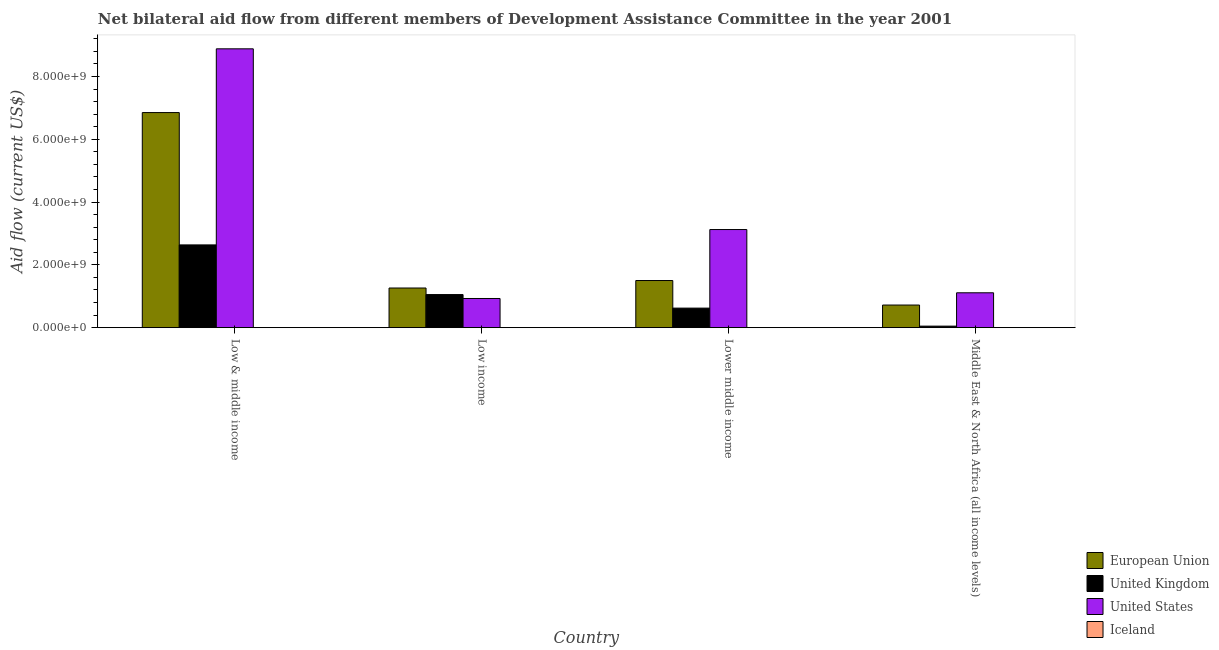How many groups of bars are there?
Ensure brevity in your answer.  4. Are the number of bars on each tick of the X-axis equal?
Provide a short and direct response. Yes. How many bars are there on the 1st tick from the left?
Your response must be concise. 4. What is the label of the 1st group of bars from the left?
Offer a very short reply. Low & middle income. In how many cases, is the number of bars for a given country not equal to the number of legend labels?
Your response must be concise. 0. What is the amount of aid given by eu in Low income?
Offer a very short reply. 1.26e+09. Across all countries, what is the maximum amount of aid given by eu?
Keep it short and to the point. 6.85e+09. Across all countries, what is the minimum amount of aid given by iceland?
Keep it short and to the point. 2.00e+04. In which country was the amount of aid given by eu minimum?
Your response must be concise. Middle East & North Africa (all income levels). What is the total amount of aid given by us in the graph?
Provide a short and direct response. 1.40e+1. What is the difference between the amount of aid given by uk in Low & middle income and that in Lower middle income?
Provide a short and direct response. 2.01e+09. What is the difference between the amount of aid given by eu in Lower middle income and the amount of aid given by uk in Low & middle income?
Keep it short and to the point. -1.13e+09. What is the average amount of aid given by us per country?
Provide a short and direct response. 3.51e+09. What is the difference between the amount of aid given by uk and amount of aid given by iceland in Lower middle income?
Provide a short and direct response. 6.21e+08. In how many countries, is the amount of aid given by us greater than 2000000000 US$?
Offer a very short reply. 2. What is the ratio of the amount of aid given by eu in Low & middle income to that in Lower middle income?
Offer a terse response. 4.56. Is the amount of aid given by uk in Lower middle income less than that in Middle East & North Africa (all income levels)?
Offer a very short reply. No. What is the difference between the highest and the second highest amount of aid given by uk?
Keep it short and to the point. 1.58e+09. What is the difference between the highest and the lowest amount of aid given by us?
Your response must be concise. 7.95e+09. Is it the case that in every country, the sum of the amount of aid given by uk and amount of aid given by us is greater than the sum of amount of aid given by iceland and amount of aid given by eu?
Your answer should be very brief. No. Is it the case that in every country, the sum of the amount of aid given by eu and amount of aid given by uk is greater than the amount of aid given by us?
Ensure brevity in your answer.  No. How many countries are there in the graph?
Keep it short and to the point. 4. What is the difference between two consecutive major ticks on the Y-axis?
Offer a terse response. 2.00e+09. How many legend labels are there?
Provide a succinct answer. 4. What is the title of the graph?
Your answer should be very brief. Net bilateral aid flow from different members of Development Assistance Committee in the year 2001. What is the label or title of the X-axis?
Make the answer very short. Country. What is the label or title of the Y-axis?
Your answer should be compact. Aid flow (current US$). What is the Aid flow (current US$) in European Union in Low & middle income?
Ensure brevity in your answer.  6.85e+09. What is the Aid flow (current US$) of United Kingdom in Low & middle income?
Ensure brevity in your answer.  2.64e+09. What is the Aid flow (current US$) in United States in Low & middle income?
Your answer should be very brief. 8.88e+09. What is the Aid flow (current US$) of Iceland in Low & middle income?
Offer a very short reply. 2.00e+04. What is the Aid flow (current US$) in European Union in Low income?
Provide a succinct answer. 1.26e+09. What is the Aid flow (current US$) of United Kingdom in Low income?
Offer a very short reply. 1.05e+09. What is the Aid flow (current US$) of United States in Low income?
Keep it short and to the point. 9.29e+08. What is the Aid flow (current US$) in Iceland in Low income?
Ensure brevity in your answer.  1.74e+06. What is the Aid flow (current US$) of European Union in Lower middle income?
Make the answer very short. 1.50e+09. What is the Aid flow (current US$) in United Kingdom in Lower middle income?
Your answer should be compact. 6.23e+08. What is the Aid flow (current US$) of United States in Lower middle income?
Provide a short and direct response. 3.13e+09. What is the Aid flow (current US$) of Iceland in Lower middle income?
Your answer should be very brief. 1.30e+06. What is the Aid flow (current US$) in European Union in Middle East & North Africa (all income levels)?
Provide a succinct answer. 7.21e+08. What is the Aid flow (current US$) in United Kingdom in Middle East & North Africa (all income levels)?
Make the answer very short. 4.88e+07. What is the Aid flow (current US$) of United States in Middle East & North Africa (all income levels)?
Offer a very short reply. 1.11e+09. What is the Aid flow (current US$) in Iceland in Middle East & North Africa (all income levels)?
Your answer should be compact. 9.70e+05. Across all countries, what is the maximum Aid flow (current US$) in European Union?
Offer a terse response. 6.85e+09. Across all countries, what is the maximum Aid flow (current US$) in United Kingdom?
Provide a succinct answer. 2.64e+09. Across all countries, what is the maximum Aid flow (current US$) in United States?
Ensure brevity in your answer.  8.88e+09. Across all countries, what is the maximum Aid flow (current US$) of Iceland?
Your response must be concise. 1.74e+06. Across all countries, what is the minimum Aid flow (current US$) in European Union?
Ensure brevity in your answer.  7.21e+08. Across all countries, what is the minimum Aid flow (current US$) in United Kingdom?
Offer a very short reply. 4.88e+07. Across all countries, what is the minimum Aid flow (current US$) in United States?
Your answer should be very brief. 9.29e+08. What is the total Aid flow (current US$) in European Union in the graph?
Your response must be concise. 1.03e+1. What is the total Aid flow (current US$) in United Kingdom in the graph?
Keep it short and to the point. 4.36e+09. What is the total Aid flow (current US$) of United States in the graph?
Your response must be concise. 1.40e+1. What is the total Aid flow (current US$) of Iceland in the graph?
Your response must be concise. 4.03e+06. What is the difference between the Aid flow (current US$) in European Union in Low & middle income and that in Low income?
Your answer should be very brief. 5.59e+09. What is the difference between the Aid flow (current US$) in United Kingdom in Low & middle income and that in Low income?
Keep it short and to the point. 1.58e+09. What is the difference between the Aid flow (current US$) in United States in Low & middle income and that in Low income?
Give a very brief answer. 7.95e+09. What is the difference between the Aid flow (current US$) of Iceland in Low & middle income and that in Low income?
Give a very brief answer. -1.72e+06. What is the difference between the Aid flow (current US$) of European Union in Low & middle income and that in Lower middle income?
Your answer should be compact. 5.35e+09. What is the difference between the Aid flow (current US$) in United Kingdom in Low & middle income and that in Lower middle income?
Make the answer very short. 2.01e+09. What is the difference between the Aid flow (current US$) of United States in Low & middle income and that in Lower middle income?
Offer a terse response. 5.76e+09. What is the difference between the Aid flow (current US$) in Iceland in Low & middle income and that in Lower middle income?
Give a very brief answer. -1.28e+06. What is the difference between the Aid flow (current US$) in European Union in Low & middle income and that in Middle East & North Africa (all income levels)?
Ensure brevity in your answer.  6.13e+09. What is the difference between the Aid flow (current US$) in United Kingdom in Low & middle income and that in Middle East & North Africa (all income levels)?
Your answer should be very brief. 2.59e+09. What is the difference between the Aid flow (current US$) in United States in Low & middle income and that in Middle East & North Africa (all income levels)?
Make the answer very short. 7.77e+09. What is the difference between the Aid flow (current US$) in Iceland in Low & middle income and that in Middle East & North Africa (all income levels)?
Keep it short and to the point. -9.50e+05. What is the difference between the Aid flow (current US$) in European Union in Low income and that in Lower middle income?
Give a very brief answer. -2.38e+08. What is the difference between the Aid flow (current US$) of United Kingdom in Low income and that in Lower middle income?
Your answer should be very brief. 4.31e+08. What is the difference between the Aid flow (current US$) of United States in Low income and that in Lower middle income?
Provide a succinct answer. -2.20e+09. What is the difference between the Aid flow (current US$) in European Union in Low income and that in Middle East & North Africa (all income levels)?
Your response must be concise. 5.42e+08. What is the difference between the Aid flow (current US$) of United Kingdom in Low income and that in Middle East & North Africa (all income levels)?
Provide a short and direct response. 1.01e+09. What is the difference between the Aid flow (current US$) in United States in Low income and that in Middle East & North Africa (all income levels)?
Your answer should be very brief. -1.82e+08. What is the difference between the Aid flow (current US$) in Iceland in Low income and that in Middle East & North Africa (all income levels)?
Provide a short and direct response. 7.70e+05. What is the difference between the Aid flow (current US$) in European Union in Lower middle income and that in Middle East & North Africa (all income levels)?
Your answer should be very brief. 7.81e+08. What is the difference between the Aid flow (current US$) of United Kingdom in Lower middle income and that in Middle East & North Africa (all income levels)?
Ensure brevity in your answer.  5.74e+08. What is the difference between the Aid flow (current US$) of United States in Lower middle income and that in Middle East & North Africa (all income levels)?
Provide a short and direct response. 2.01e+09. What is the difference between the Aid flow (current US$) in Iceland in Lower middle income and that in Middle East & North Africa (all income levels)?
Ensure brevity in your answer.  3.30e+05. What is the difference between the Aid flow (current US$) of European Union in Low & middle income and the Aid flow (current US$) of United Kingdom in Low income?
Offer a very short reply. 5.80e+09. What is the difference between the Aid flow (current US$) in European Union in Low & middle income and the Aid flow (current US$) in United States in Low income?
Keep it short and to the point. 5.92e+09. What is the difference between the Aid flow (current US$) in European Union in Low & middle income and the Aid flow (current US$) in Iceland in Low income?
Offer a very short reply. 6.85e+09. What is the difference between the Aid flow (current US$) of United Kingdom in Low & middle income and the Aid flow (current US$) of United States in Low income?
Your answer should be compact. 1.71e+09. What is the difference between the Aid flow (current US$) in United Kingdom in Low & middle income and the Aid flow (current US$) in Iceland in Low income?
Offer a terse response. 2.63e+09. What is the difference between the Aid flow (current US$) in United States in Low & middle income and the Aid flow (current US$) in Iceland in Low income?
Make the answer very short. 8.88e+09. What is the difference between the Aid flow (current US$) in European Union in Low & middle income and the Aid flow (current US$) in United Kingdom in Lower middle income?
Your answer should be very brief. 6.23e+09. What is the difference between the Aid flow (current US$) in European Union in Low & middle income and the Aid flow (current US$) in United States in Lower middle income?
Your response must be concise. 3.73e+09. What is the difference between the Aid flow (current US$) in European Union in Low & middle income and the Aid flow (current US$) in Iceland in Lower middle income?
Give a very brief answer. 6.85e+09. What is the difference between the Aid flow (current US$) in United Kingdom in Low & middle income and the Aid flow (current US$) in United States in Lower middle income?
Offer a very short reply. -4.89e+08. What is the difference between the Aid flow (current US$) in United Kingdom in Low & middle income and the Aid flow (current US$) in Iceland in Lower middle income?
Offer a very short reply. 2.63e+09. What is the difference between the Aid flow (current US$) in United States in Low & middle income and the Aid flow (current US$) in Iceland in Lower middle income?
Your response must be concise. 8.88e+09. What is the difference between the Aid flow (current US$) in European Union in Low & middle income and the Aid flow (current US$) in United Kingdom in Middle East & North Africa (all income levels)?
Keep it short and to the point. 6.80e+09. What is the difference between the Aid flow (current US$) in European Union in Low & middle income and the Aid flow (current US$) in United States in Middle East & North Africa (all income levels)?
Provide a succinct answer. 5.74e+09. What is the difference between the Aid flow (current US$) in European Union in Low & middle income and the Aid flow (current US$) in Iceland in Middle East & North Africa (all income levels)?
Offer a terse response. 6.85e+09. What is the difference between the Aid flow (current US$) in United Kingdom in Low & middle income and the Aid flow (current US$) in United States in Middle East & North Africa (all income levels)?
Give a very brief answer. 1.53e+09. What is the difference between the Aid flow (current US$) of United Kingdom in Low & middle income and the Aid flow (current US$) of Iceland in Middle East & North Africa (all income levels)?
Ensure brevity in your answer.  2.64e+09. What is the difference between the Aid flow (current US$) of United States in Low & middle income and the Aid flow (current US$) of Iceland in Middle East & North Africa (all income levels)?
Keep it short and to the point. 8.88e+09. What is the difference between the Aid flow (current US$) in European Union in Low income and the Aid flow (current US$) in United Kingdom in Lower middle income?
Offer a very short reply. 6.41e+08. What is the difference between the Aid flow (current US$) in European Union in Low income and the Aid flow (current US$) in United States in Lower middle income?
Provide a succinct answer. -1.86e+09. What is the difference between the Aid flow (current US$) of European Union in Low income and the Aid flow (current US$) of Iceland in Lower middle income?
Ensure brevity in your answer.  1.26e+09. What is the difference between the Aid flow (current US$) in United Kingdom in Low income and the Aid flow (current US$) in United States in Lower middle income?
Make the answer very short. -2.07e+09. What is the difference between the Aid flow (current US$) of United Kingdom in Low income and the Aid flow (current US$) of Iceland in Lower middle income?
Your answer should be compact. 1.05e+09. What is the difference between the Aid flow (current US$) of United States in Low income and the Aid flow (current US$) of Iceland in Lower middle income?
Your answer should be compact. 9.28e+08. What is the difference between the Aid flow (current US$) of European Union in Low income and the Aid flow (current US$) of United Kingdom in Middle East & North Africa (all income levels)?
Offer a very short reply. 1.21e+09. What is the difference between the Aid flow (current US$) in European Union in Low income and the Aid flow (current US$) in United States in Middle East & North Africa (all income levels)?
Provide a short and direct response. 1.52e+08. What is the difference between the Aid flow (current US$) of European Union in Low income and the Aid flow (current US$) of Iceland in Middle East & North Africa (all income levels)?
Give a very brief answer. 1.26e+09. What is the difference between the Aid flow (current US$) of United Kingdom in Low income and the Aid flow (current US$) of United States in Middle East & North Africa (all income levels)?
Your answer should be very brief. -5.69e+07. What is the difference between the Aid flow (current US$) in United Kingdom in Low income and the Aid flow (current US$) in Iceland in Middle East & North Africa (all income levels)?
Your answer should be compact. 1.05e+09. What is the difference between the Aid flow (current US$) of United States in Low income and the Aid flow (current US$) of Iceland in Middle East & North Africa (all income levels)?
Your response must be concise. 9.28e+08. What is the difference between the Aid flow (current US$) of European Union in Lower middle income and the Aid flow (current US$) of United Kingdom in Middle East & North Africa (all income levels)?
Offer a very short reply. 1.45e+09. What is the difference between the Aid flow (current US$) of European Union in Lower middle income and the Aid flow (current US$) of United States in Middle East & North Africa (all income levels)?
Make the answer very short. 3.90e+08. What is the difference between the Aid flow (current US$) in European Union in Lower middle income and the Aid flow (current US$) in Iceland in Middle East & North Africa (all income levels)?
Provide a short and direct response. 1.50e+09. What is the difference between the Aid flow (current US$) in United Kingdom in Lower middle income and the Aid flow (current US$) in United States in Middle East & North Africa (all income levels)?
Offer a terse response. -4.88e+08. What is the difference between the Aid flow (current US$) in United Kingdom in Lower middle income and the Aid flow (current US$) in Iceland in Middle East & North Africa (all income levels)?
Make the answer very short. 6.22e+08. What is the difference between the Aid flow (current US$) in United States in Lower middle income and the Aid flow (current US$) in Iceland in Middle East & North Africa (all income levels)?
Your answer should be very brief. 3.12e+09. What is the average Aid flow (current US$) of European Union per country?
Your answer should be very brief. 2.58e+09. What is the average Aid flow (current US$) of United Kingdom per country?
Offer a terse response. 1.09e+09. What is the average Aid flow (current US$) in United States per country?
Provide a succinct answer. 3.51e+09. What is the average Aid flow (current US$) in Iceland per country?
Your answer should be very brief. 1.01e+06. What is the difference between the Aid flow (current US$) of European Union and Aid flow (current US$) of United Kingdom in Low & middle income?
Offer a terse response. 4.21e+09. What is the difference between the Aid flow (current US$) in European Union and Aid flow (current US$) in United States in Low & middle income?
Provide a short and direct response. -2.03e+09. What is the difference between the Aid flow (current US$) in European Union and Aid flow (current US$) in Iceland in Low & middle income?
Your answer should be compact. 6.85e+09. What is the difference between the Aid flow (current US$) in United Kingdom and Aid flow (current US$) in United States in Low & middle income?
Offer a terse response. -6.25e+09. What is the difference between the Aid flow (current US$) of United Kingdom and Aid flow (current US$) of Iceland in Low & middle income?
Give a very brief answer. 2.64e+09. What is the difference between the Aid flow (current US$) of United States and Aid flow (current US$) of Iceland in Low & middle income?
Your answer should be compact. 8.88e+09. What is the difference between the Aid flow (current US$) in European Union and Aid flow (current US$) in United Kingdom in Low income?
Your response must be concise. 2.09e+08. What is the difference between the Aid flow (current US$) in European Union and Aid flow (current US$) in United States in Low income?
Offer a very short reply. 3.34e+08. What is the difference between the Aid flow (current US$) in European Union and Aid flow (current US$) in Iceland in Low income?
Offer a terse response. 1.26e+09. What is the difference between the Aid flow (current US$) of United Kingdom and Aid flow (current US$) of United States in Low income?
Ensure brevity in your answer.  1.25e+08. What is the difference between the Aid flow (current US$) of United Kingdom and Aid flow (current US$) of Iceland in Low income?
Your answer should be compact. 1.05e+09. What is the difference between the Aid flow (current US$) in United States and Aid flow (current US$) in Iceland in Low income?
Offer a terse response. 9.27e+08. What is the difference between the Aid flow (current US$) in European Union and Aid flow (current US$) in United Kingdom in Lower middle income?
Your answer should be compact. 8.79e+08. What is the difference between the Aid flow (current US$) of European Union and Aid flow (current US$) of United States in Lower middle income?
Provide a succinct answer. -1.62e+09. What is the difference between the Aid flow (current US$) of European Union and Aid flow (current US$) of Iceland in Lower middle income?
Your answer should be very brief. 1.50e+09. What is the difference between the Aid flow (current US$) in United Kingdom and Aid flow (current US$) in United States in Lower middle income?
Provide a short and direct response. -2.50e+09. What is the difference between the Aid flow (current US$) in United Kingdom and Aid flow (current US$) in Iceland in Lower middle income?
Offer a very short reply. 6.21e+08. What is the difference between the Aid flow (current US$) in United States and Aid flow (current US$) in Iceland in Lower middle income?
Your response must be concise. 3.12e+09. What is the difference between the Aid flow (current US$) of European Union and Aid flow (current US$) of United Kingdom in Middle East & North Africa (all income levels)?
Offer a terse response. 6.72e+08. What is the difference between the Aid flow (current US$) of European Union and Aid flow (current US$) of United States in Middle East & North Africa (all income levels)?
Your answer should be compact. -3.90e+08. What is the difference between the Aid flow (current US$) of European Union and Aid flow (current US$) of Iceland in Middle East & North Africa (all income levels)?
Offer a terse response. 7.20e+08. What is the difference between the Aid flow (current US$) of United Kingdom and Aid flow (current US$) of United States in Middle East & North Africa (all income levels)?
Provide a short and direct response. -1.06e+09. What is the difference between the Aid flow (current US$) of United Kingdom and Aid flow (current US$) of Iceland in Middle East & North Africa (all income levels)?
Ensure brevity in your answer.  4.78e+07. What is the difference between the Aid flow (current US$) in United States and Aid flow (current US$) in Iceland in Middle East & North Africa (all income levels)?
Offer a terse response. 1.11e+09. What is the ratio of the Aid flow (current US$) of European Union in Low & middle income to that in Low income?
Your answer should be very brief. 5.42. What is the ratio of the Aid flow (current US$) in United Kingdom in Low & middle income to that in Low income?
Your response must be concise. 2.5. What is the ratio of the Aid flow (current US$) in United States in Low & middle income to that in Low income?
Give a very brief answer. 9.56. What is the ratio of the Aid flow (current US$) in Iceland in Low & middle income to that in Low income?
Give a very brief answer. 0.01. What is the ratio of the Aid flow (current US$) of European Union in Low & middle income to that in Lower middle income?
Ensure brevity in your answer.  4.56. What is the ratio of the Aid flow (current US$) of United Kingdom in Low & middle income to that in Lower middle income?
Keep it short and to the point. 4.23. What is the ratio of the Aid flow (current US$) of United States in Low & middle income to that in Lower middle income?
Provide a succinct answer. 2.84. What is the ratio of the Aid flow (current US$) in Iceland in Low & middle income to that in Lower middle income?
Your response must be concise. 0.02. What is the ratio of the Aid flow (current US$) of European Union in Low & middle income to that in Middle East & North Africa (all income levels)?
Your answer should be compact. 9.51. What is the ratio of the Aid flow (current US$) of United Kingdom in Low & middle income to that in Middle East & North Africa (all income levels)?
Offer a terse response. 54. What is the ratio of the Aid flow (current US$) in United States in Low & middle income to that in Middle East & North Africa (all income levels)?
Make the answer very short. 7.99. What is the ratio of the Aid flow (current US$) of Iceland in Low & middle income to that in Middle East & North Africa (all income levels)?
Provide a succinct answer. 0.02. What is the ratio of the Aid flow (current US$) of European Union in Low income to that in Lower middle income?
Offer a very short reply. 0.84. What is the ratio of the Aid flow (current US$) in United Kingdom in Low income to that in Lower middle income?
Ensure brevity in your answer.  1.69. What is the ratio of the Aid flow (current US$) of United States in Low income to that in Lower middle income?
Your answer should be compact. 0.3. What is the ratio of the Aid flow (current US$) of Iceland in Low income to that in Lower middle income?
Your response must be concise. 1.34. What is the ratio of the Aid flow (current US$) in European Union in Low income to that in Middle East & North Africa (all income levels)?
Your answer should be very brief. 1.75. What is the ratio of the Aid flow (current US$) of United Kingdom in Low income to that in Middle East & North Africa (all income levels)?
Ensure brevity in your answer.  21.59. What is the ratio of the Aid flow (current US$) of United States in Low income to that in Middle East & North Africa (all income levels)?
Provide a short and direct response. 0.84. What is the ratio of the Aid flow (current US$) in Iceland in Low income to that in Middle East & North Africa (all income levels)?
Your answer should be very brief. 1.79. What is the ratio of the Aid flow (current US$) of European Union in Lower middle income to that in Middle East & North Africa (all income levels)?
Your answer should be compact. 2.08. What is the ratio of the Aid flow (current US$) in United Kingdom in Lower middle income to that in Middle East & North Africa (all income levels)?
Ensure brevity in your answer.  12.75. What is the ratio of the Aid flow (current US$) of United States in Lower middle income to that in Middle East & North Africa (all income levels)?
Offer a terse response. 2.81. What is the ratio of the Aid flow (current US$) in Iceland in Lower middle income to that in Middle East & North Africa (all income levels)?
Ensure brevity in your answer.  1.34. What is the difference between the highest and the second highest Aid flow (current US$) in European Union?
Make the answer very short. 5.35e+09. What is the difference between the highest and the second highest Aid flow (current US$) of United Kingdom?
Make the answer very short. 1.58e+09. What is the difference between the highest and the second highest Aid flow (current US$) of United States?
Your answer should be very brief. 5.76e+09. What is the difference between the highest and the second highest Aid flow (current US$) of Iceland?
Your response must be concise. 4.40e+05. What is the difference between the highest and the lowest Aid flow (current US$) of European Union?
Your answer should be compact. 6.13e+09. What is the difference between the highest and the lowest Aid flow (current US$) in United Kingdom?
Provide a succinct answer. 2.59e+09. What is the difference between the highest and the lowest Aid flow (current US$) in United States?
Your response must be concise. 7.95e+09. What is the difference between the highest and the lowest Aid flow (current US$) in Iceland?
Keep it short and to the point. 1.72e+06. 